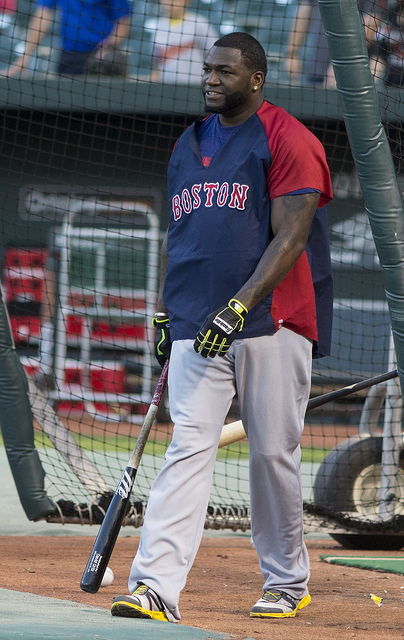Read all the text in this image. BOSTON 